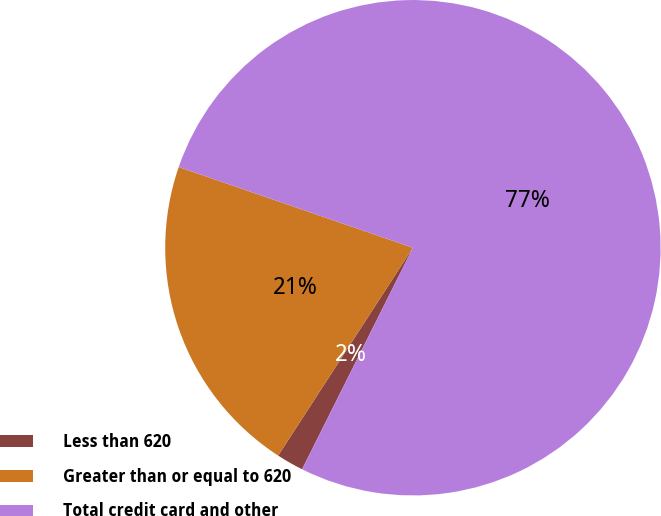<chart> <loc_0><loc_0><loc_500><loc_500><pie_chart><fcel>Less than 620<fcel>Greater than or equal to 620<fcel>Total credit card and other<nl><fcel>1.77%<fcel>21.13%<fcel>77.1%<nl></chart> 